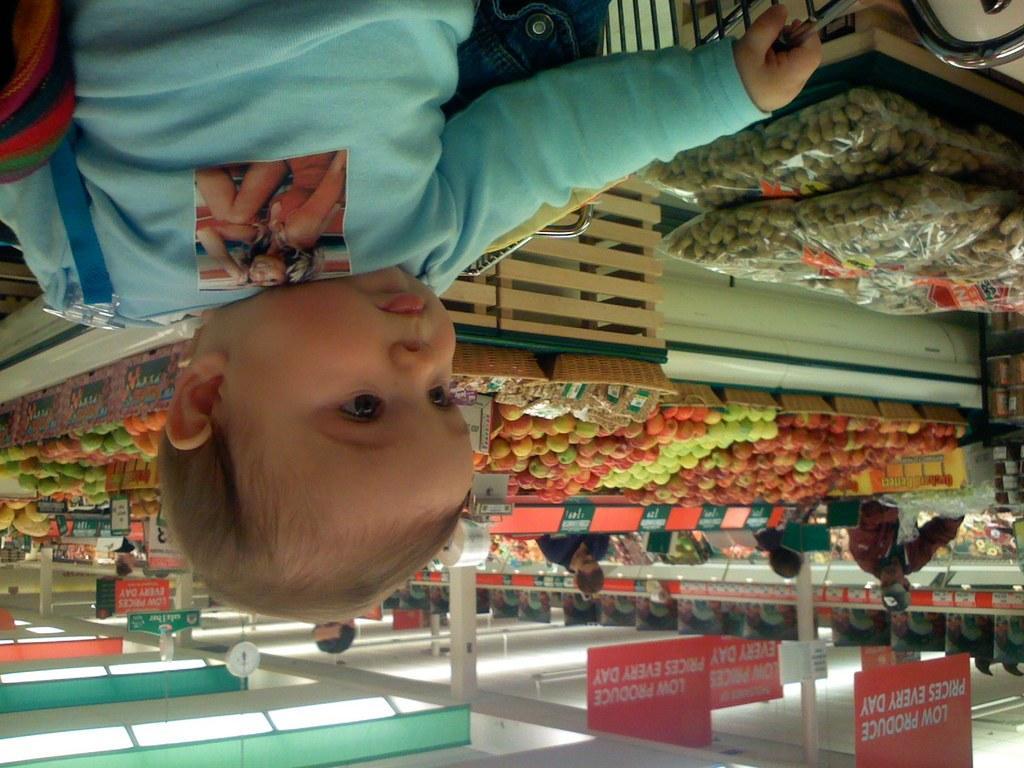How would you summarize this image in a sentence or two? In the picture we can see a baby in blue T-shirt and behind the baby we can see baskets with full of fruits and some people standing and to the ceiling we can see the lights and boards. 